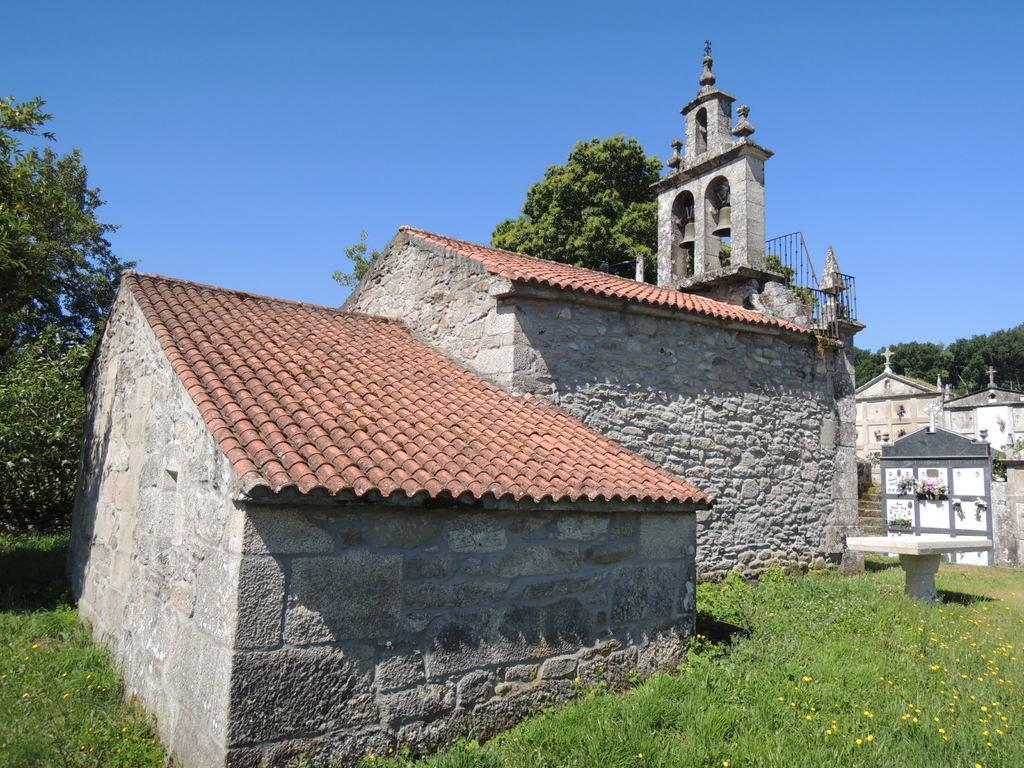What type of structures can be seen in the image? There are houses in the image. What type of architectural feature is present in the image? There is railing in the image. What type of furniture is present in the image? There is a table in the image. What type of natural environment is visible in the image? The ground is visible in the image and has grass, and there are trees in the image. What part of the natural environment is visible in the image? The sky is visible in the image. What type of error can be seen in the image? There is no error present in the image. What time of day is it in the image? The time of day is not specified in the image. What type of vehicle is present in the image? There is no vehicle present in the image. 